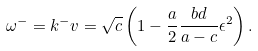<formula> <loc_0><loc_0><loc_500><loc_500>\omega ^ { - } = k ^ { - } v = \sqrt { c } \left ( 1 - \frac { a } { 2 } \frac { b d } { a - c } \epsilon ^ { 2 } \right ) .</formula> 